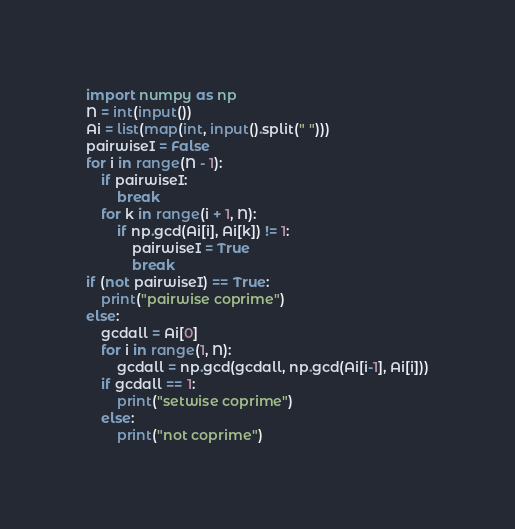Convert code to text. <code><loc_0><loc_0><loc_500><loc_500><_Python_>import numpy as np
N = int(input())
Ai = list(map(int, input().split(" ")))
pairwiseI = False
for i in range(N - 1):
    if pairwiseI:
        break
    for k in range(i + 1, N):
        if np.gcd(Ai[i], Ai[k]) != 1:
            pairwiseI = True
            break
if (not pairwiseI) == True:
    print("pairwise coprime")
else:
    gcdall = Ai[0]
    for i in range(1, N):
        gcdall = np.gcd(gcdall, np.gcd(Ai[i-1], Ai[i]))
    if gcdall == 1:
        print("setwise coprime")
    else:
        print("not coprime")</code> 